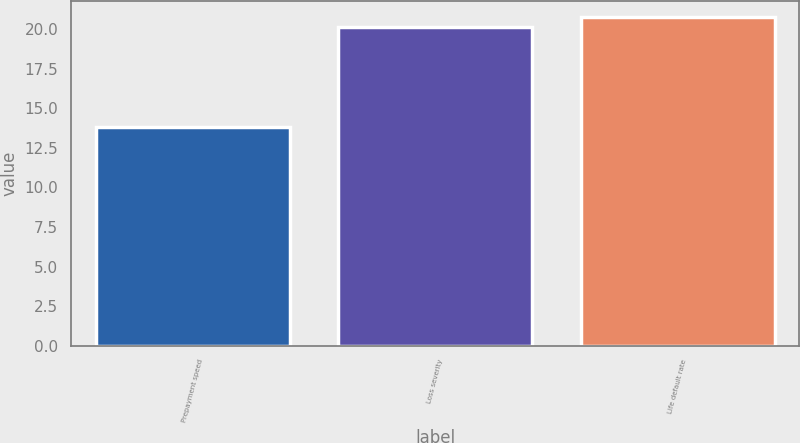Convert chart. <chart><loc_0><loc_0><loc_500><loc_500><bar_chart><fcel>Prepayment speed<fcel>Loss severity<fcel>Life default rate<nl><fcel>13.8<fcel>20.1<fcel>20.76<nl></chart> 